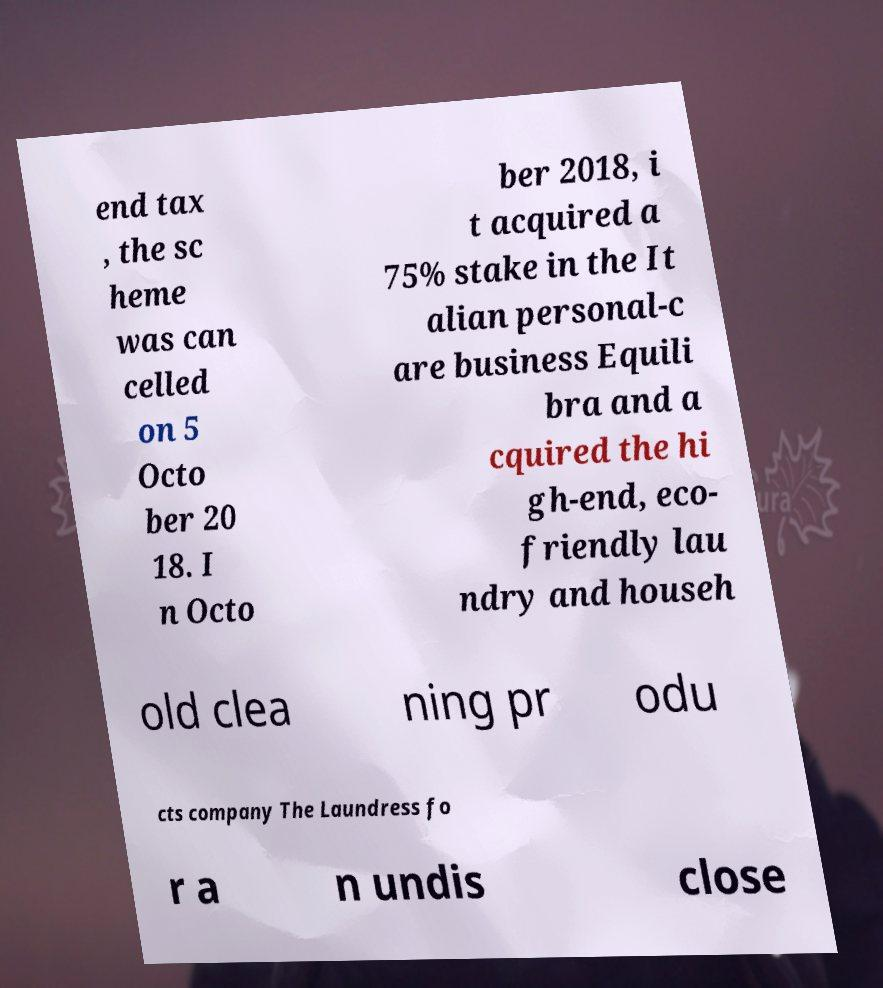There's text embedded in this image that I need extracted. Can you transcribe it verbatim? end tax , the sc heme was can celled on 5 Octo ber 20 18. I n Octo ber 2018, i t acquired a 75% stake in the It alian personal-c are business Equili bra and a cquired the hi gh-end, eco- friendly lau ndry and househ old clea ning pr odu cts company The Laundress fo r a n undis close 